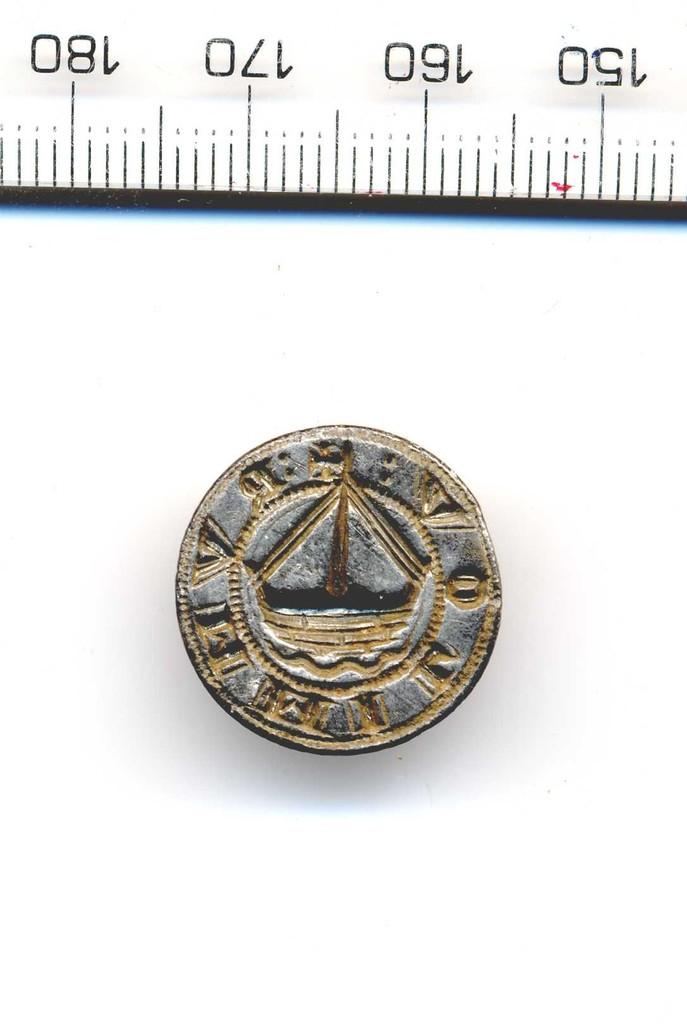Provide a one-sentence caption for the provided image. Small piece of tarnished metal embossed with a boat in the center with a ruler at top numbering the sequence 150,160,170,180. 